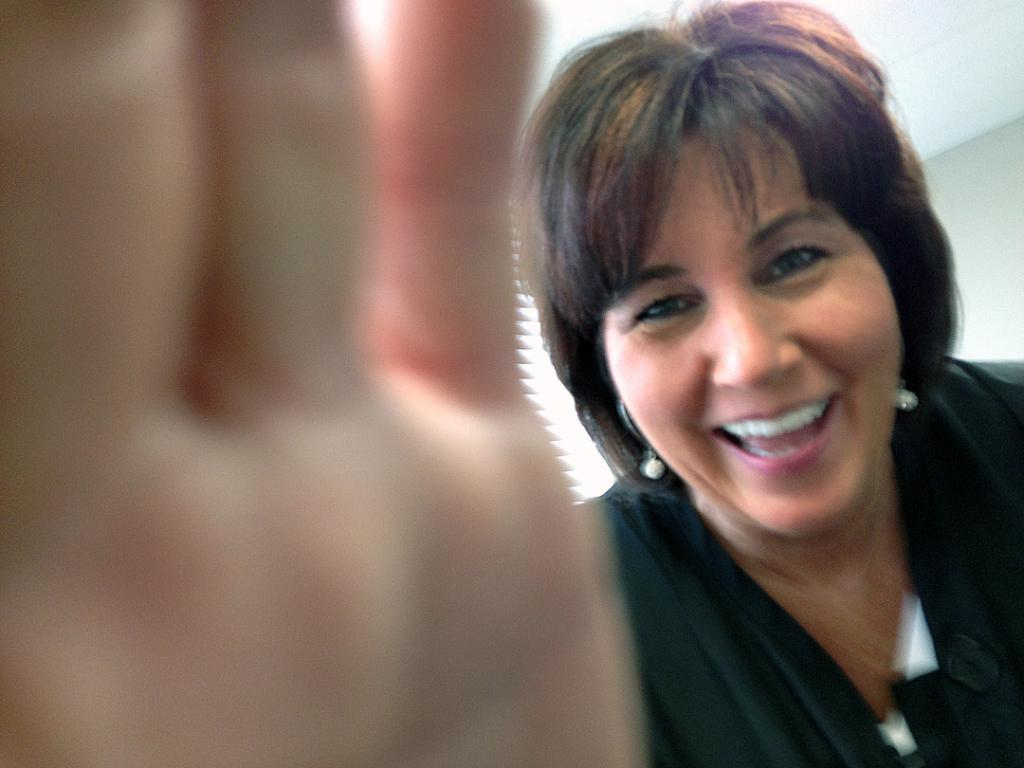What is present in the image? There is a person in the image. Can you describe the person's appearance? The person is wearing clothes. Where is the person's hand located in the image? There is a person's hand on the left side of the image. What type of pie is being served on the quiet plastic plate in the image? There is no pie or plastic plate present in the image; it only features a person with a hand on the left side. 